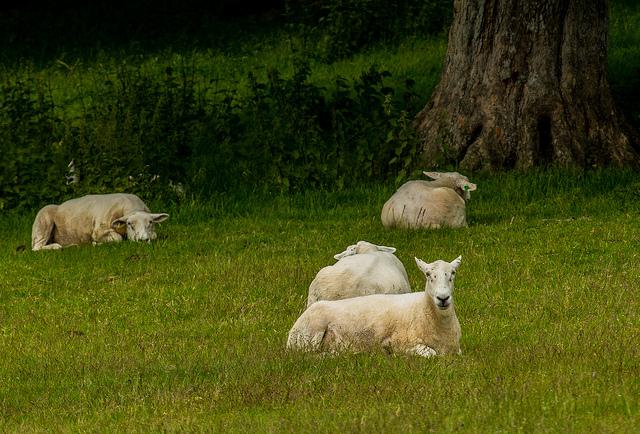How many sheep are laying in the field?
Answer briefly. 4. How many pairs of ears do you see?
Give a very brief answer. 4. What color is the middle cow?
Short answer required. White. How many animals are in the photo?
Quick response, please. 4. Is it a sunny day?
Be succinct. Yes. What are the animals doing?
Concise answer only. Resting. Are the sheep standing or lying down?
Concise answer only. Laying down. 